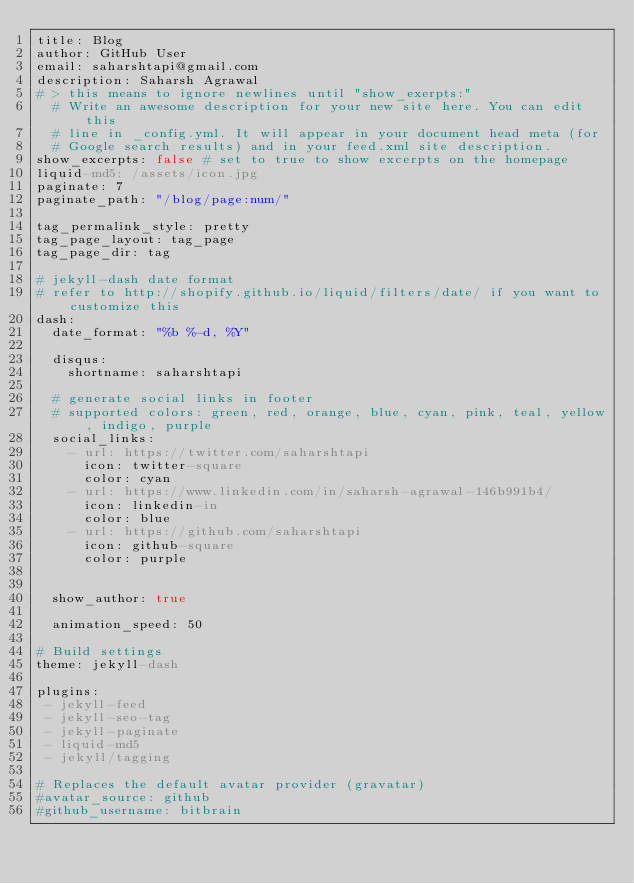Convert code to text. <code><loc_0><loc_0><loc_500><loc_500><_YAML_>title: Blog
author: GitHub User
email: saharshtapi@gmail.com
description: Saharsh Agrawal
# > this means to ignore newlines until "show_exerpts:"
  # Write an awesome description for your new site here. You can edit this
  # line in _config.yml. It will appear in your document head meta (for
  # Google search results) and in your feed.xml site description.
show_excerpts: false # set to true to show excerpts on the homepage
liquid-md5: /assets/icon.jpg
paginate: 7
paginate_path: "/blog/page:num/"

tag_permalink_style: pretty
tag_page_layout: tag_page
tag_page_dir: tag

# jekyll-dash date format
# refer to http://shopify.github.io/liquid/filters/date/ if you want to customize this
dash:
  date_format: "%b %-d, %Y"

  disqus:
    shortname: saharshtapi

  # generate social links in footer
  # supported colors: green, red, orange, blue, cyan, pink, teal, yellow, indigo, purple
  social_links:
    - url: https://twitter.com/saharshtapi
      icon: twitter-square
      color: cyan
    - url: https://www.linkedin.com/in/saharsh-agrawal-146b991b4/
      icon: linkedin-in
      color: blue
    - url: https://github.com/saharshtapi
      icon: github-square
      color: purple


  show_author: true

  animation_speed: 50

# Build settings
theme: jekyll-dash

plugins:
 - jekyll-feed
 - jekyll-seo-tag
 - jekyll-paginate
 - liquid-md5
 - jekyll/tagging

# Replaces the default avatar provider (gravatar)
#avatar_source: github
#github_username: bitbrain
</code> 